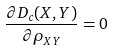<formula> <loc_0><loc_0><loc_500><loc_500>\frac { \partial D _ { c } ( X , Y ) } { \partial \rho _ { X Y } } = 0</formula> 